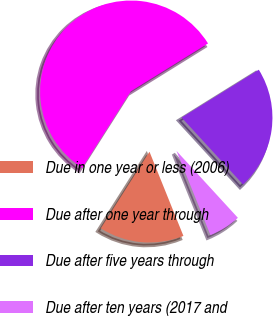<chart> <loc_0><loc_0><loc_500><loc_500><pie_chart><fcel>Due in one year or less (2006)<fcel>Due after one year through<fcel>Due after five years through<fcel>Due after ten years (2017 and<nl><fcel>15.11%<fcel>57.15%<fcel>22.02%<fcel>5.72%<nl></chart> 